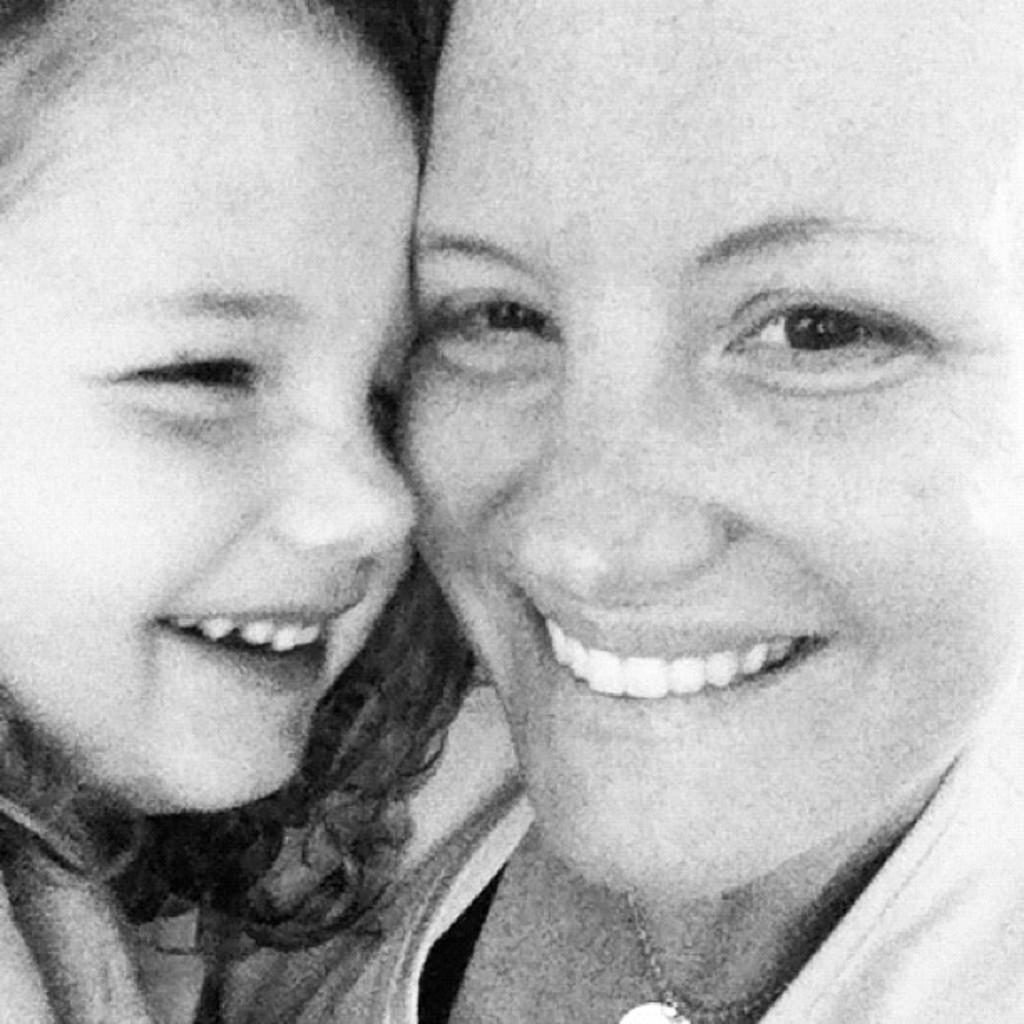Who is present in the image? There is a woman and a girl in the image. What are the expressions on their faces? Both the woman and the girl are smiling. What type of pies are being cut with the scissors in the image? There are no pies or scissors present in the image. How many beans can be seen on the girl's plate in the image? There are no beans present in the image. 